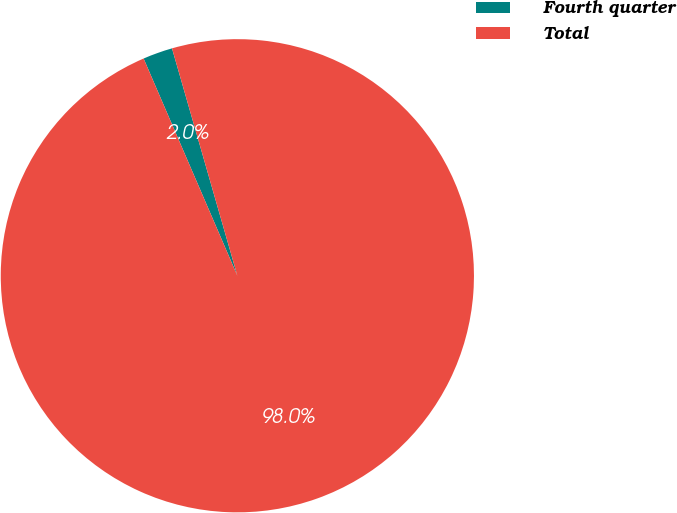Convert chart. <chart><loc_0><loc_0><loc_500><loc_500><pie_chart><fcel>Fourth quarter<fcel>Total<nl><fcel>2.03%<fcel>97.97%<nl></chart> 